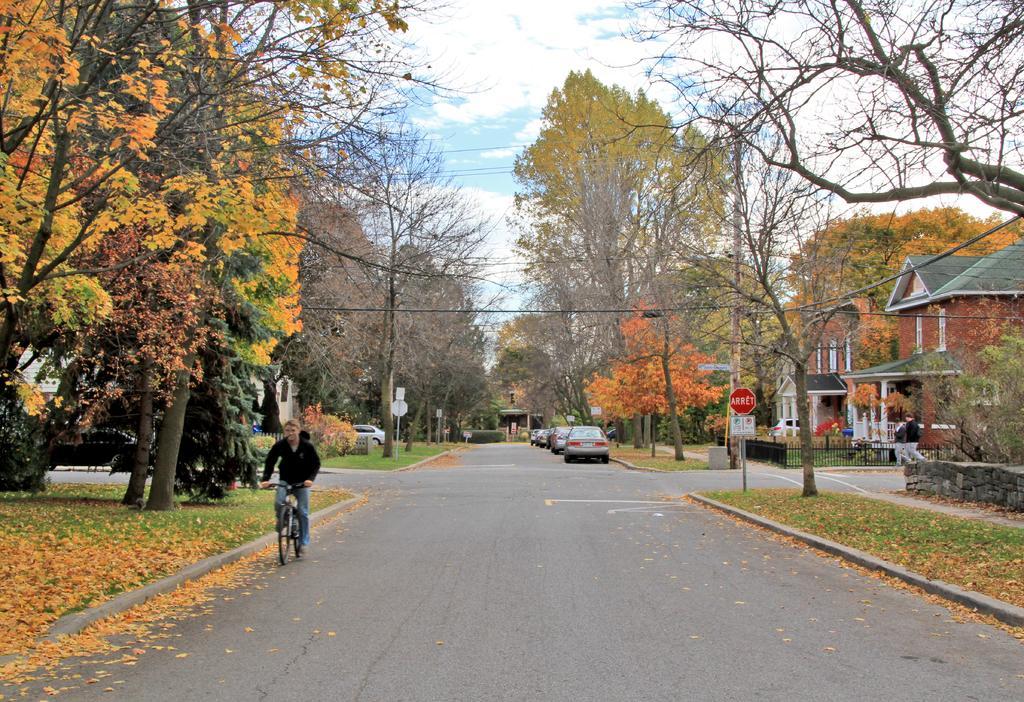How would you summarize this image in a sentence or two? In this image in the center there is a person riding a bicycle. In the background there are trees, there are vehicles, there's grass on the ground, there are persons walking, there are buildings, there is a board with some text written on it, there is a fence and in the front there are dry leaves on the ground and the sky is cloudy. 